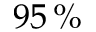Convert formula to latex. <formula><loc_0><loc_0><loc_500><loc_500>9 5 \, \%</formula> 